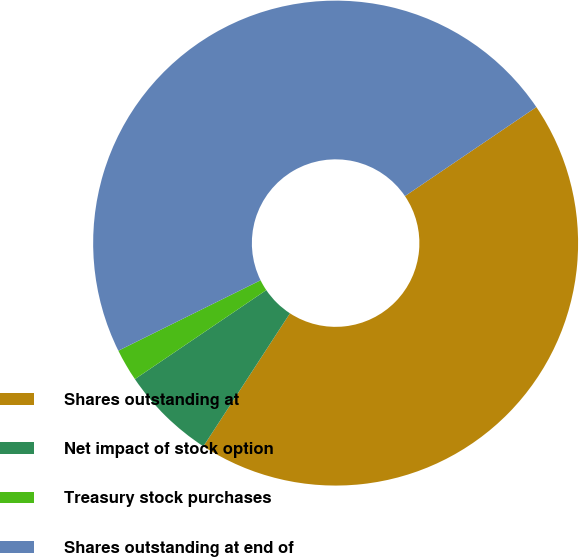<chart> <loc_0><loc_0><loc_500><loc_500><pie_chart><fcel>Shares outstanding at<fcel>Net impact of stock option<fcel>Treasury stock purchases<fcel>Shares outstanding at end of<nl><fcel>43.66%<fcel>6.34%<fcel>2.16%<fcel>47.84%<nl></chart> 